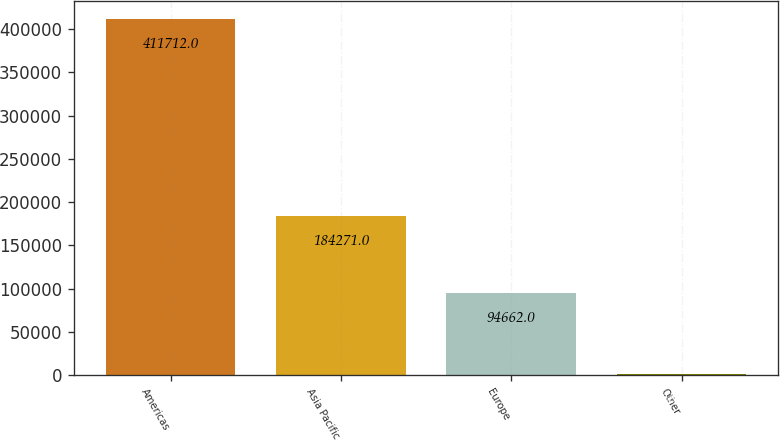<chart> <loc_0><loc_0><loc_500><loc_500><bar_chart><fcel>Americas<fcel>Asia Pacific<fcel>Europe<fcel>Other<nl><fcel>411712<fcel>184271<fcel>94662<fcel>1819<nl></chart> 